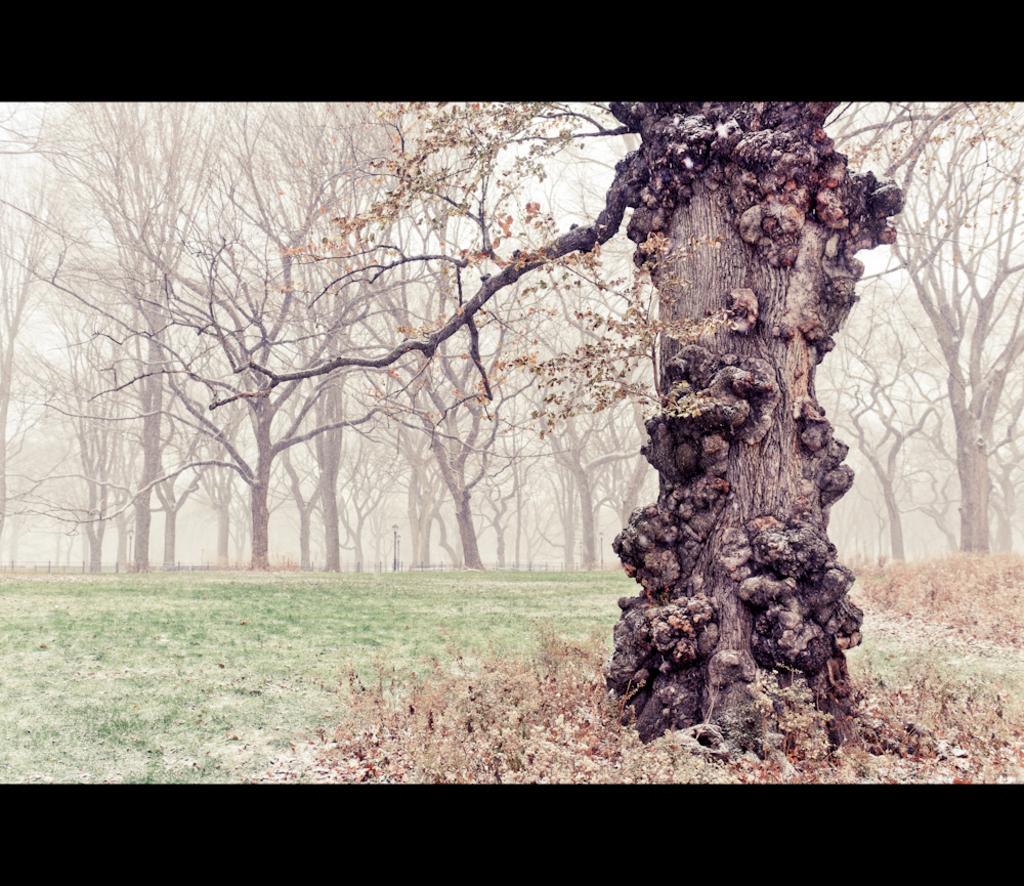Could you give a brief overview of what you see in this image? In this image we can see a group of trees and the sky. 